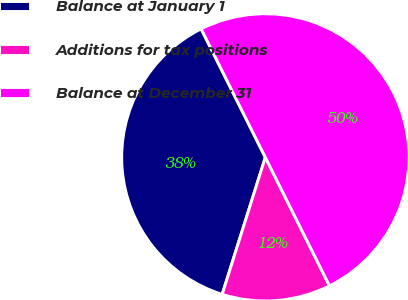Convert chart. <chart><loc_0><loc_0><loc_500><loc_500><pie_chart><fcel>Balance at January 1<fcel>Additions for tax positions<fcel>Balance at December 31<nl><fcel>37.77%<fcel>12.23%<fcel>50.0%<nl></chart> 